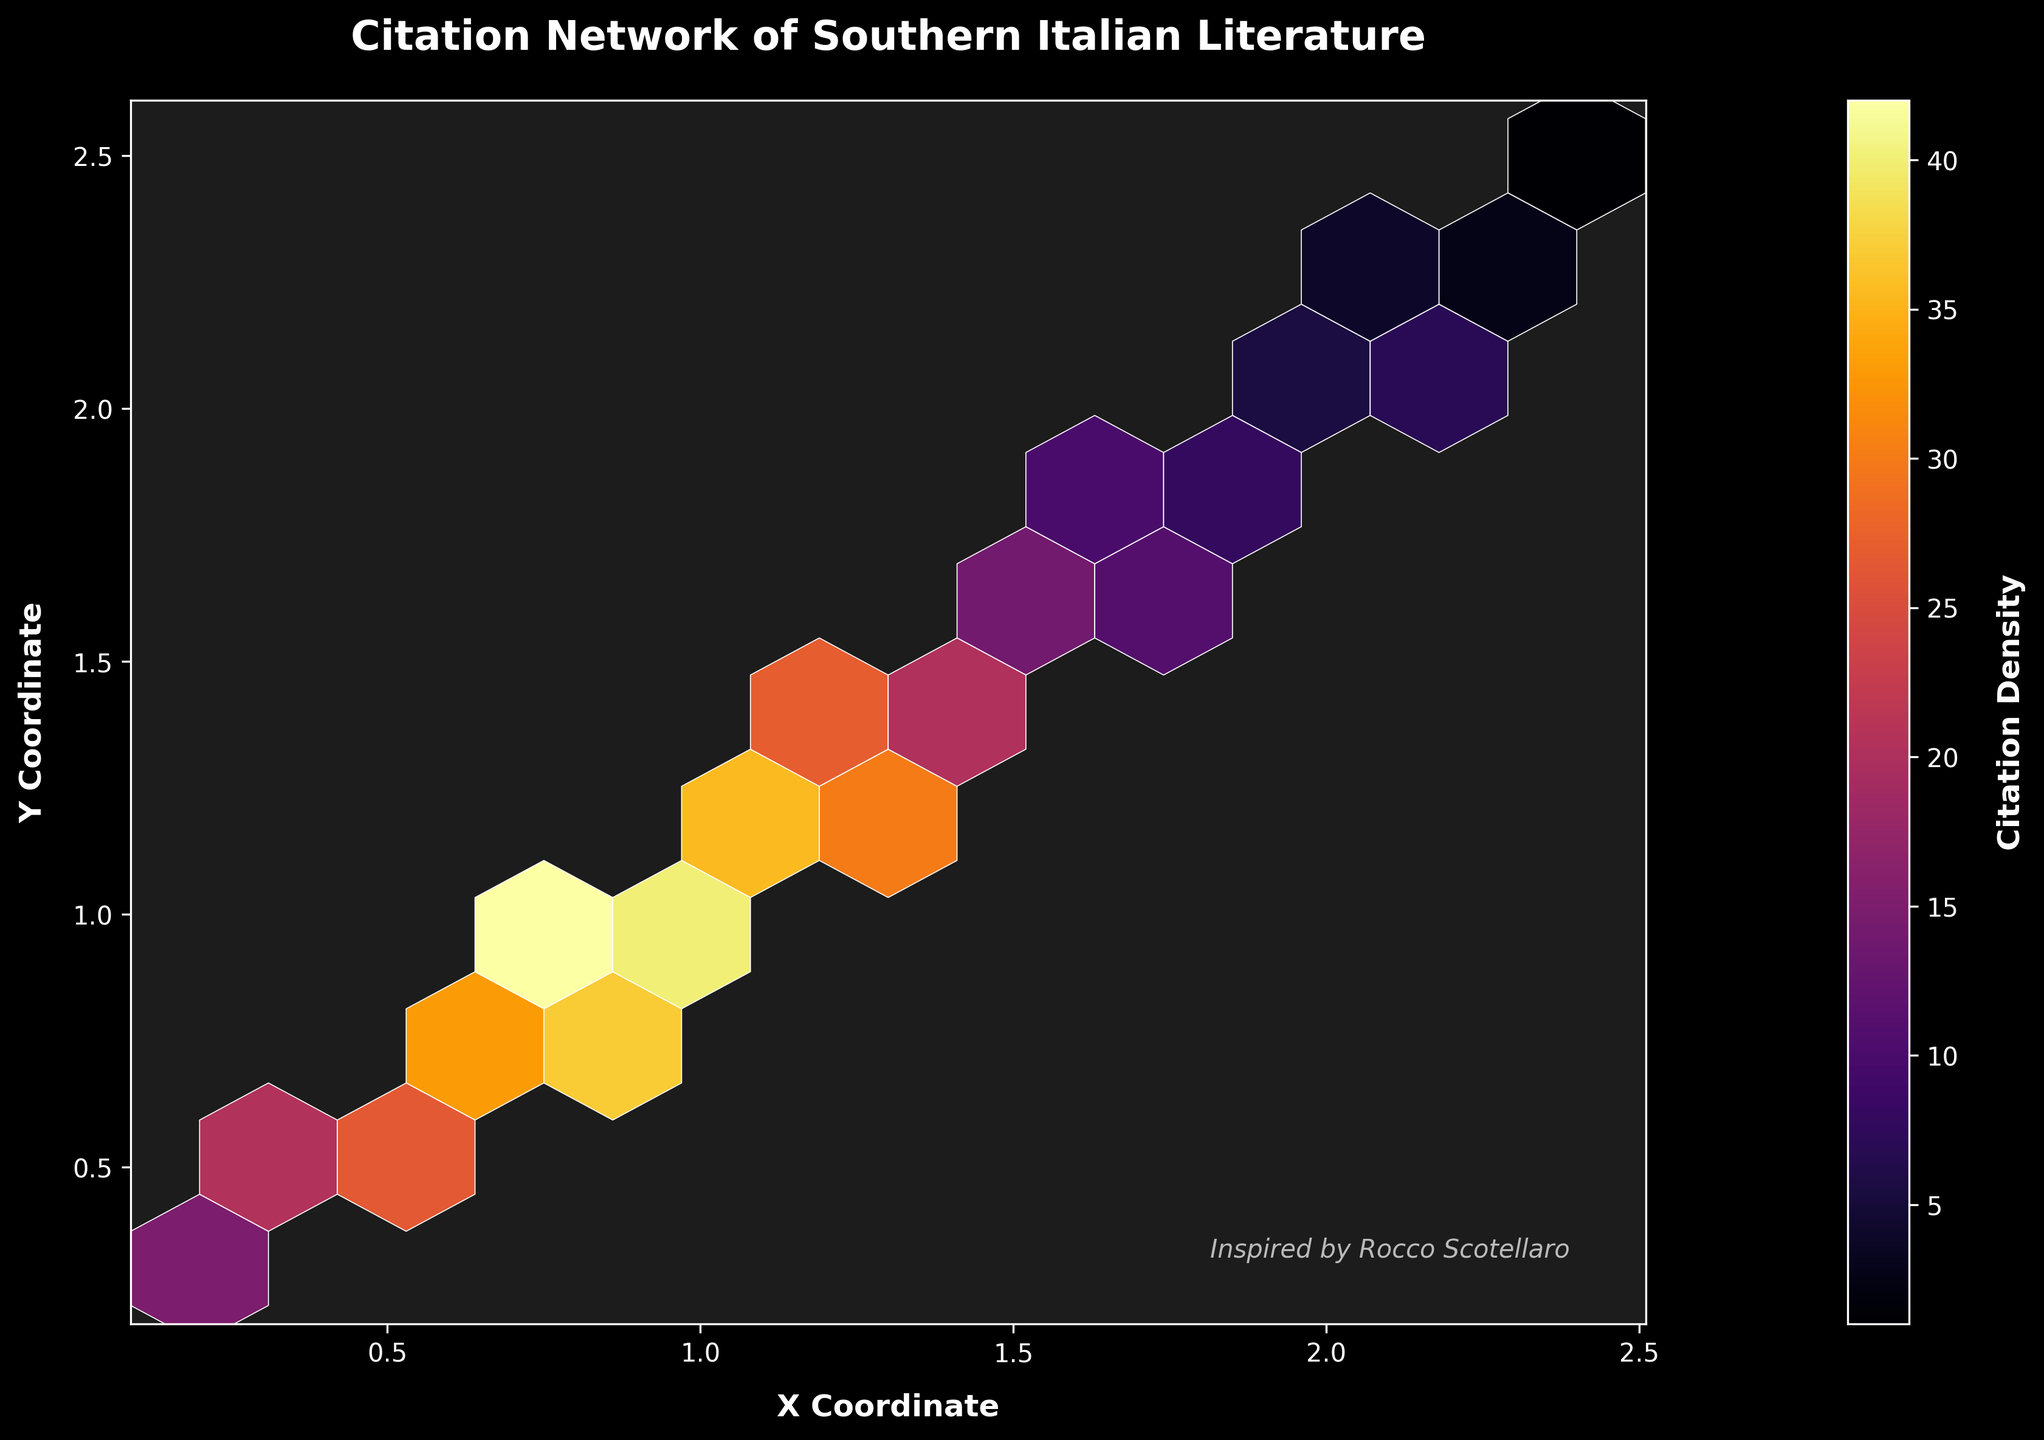What is the title of the plot? Look at the top of the figure where the title is usually located. It reads "Citation Network of Southern Italian Literature".
Answer: Citation Network of Southern Italian Literature What does the colorbar represent? A colorbar is usually placed next to the plot to show what the colors represent. Here, it is labeled as "Citation Density".
Answer: Citation Density Which of the two coordinates, X or Y, has higher values concentrated in the plot? By examining the plot, the density of darker/heavier colors (representing higher citation density) is more concentrated in the middle range of both the X and Y coordinates, but particularly noticeable along the X axis.
Answer: X Coordinate What color scheme is used in the plot? Looking at the colors in the plot, the plot uses a gradient that goes from yellow to dark red as shown in the colorbar, which corresponds to the "inferno" color scheme.
Answer: Inferno Where on the plot are the highest citation densities located? The highest citation densities are indicated by the darkest hexagons. By examining the plot, they seem to be clustered around the middle sections of the X and Y axes, particularly around the coordinates (1, 1).
Answer: Around (1, 1) What is the grid size of the hexbin plot? By counting the hexagons along one axis and confirming it with the figure's description, the grid size is determined to be 10.
Answer: 10 How many points have the highest citation density? The colorbar shows the range of citation densities. By checking the hexagons' colors against the darkest color in the colorbar, it seems that very few (maybe 1 or 2) hexagons hold the highest citation density.
Answer: 1 or 2 Which axis has a label written in bold text? By looking at the axes, the labeling style is noticed. Both the X and Y axes labels are written in bold text, labeled as "X Coordinate" and "Y Coordinate".
Answer: Both What is the position of the text inspired by Rocco Scotellaro? Look at the plot for additional text. The text "Inspired by Rocco Scotellaro" is located at the bottom right corner of the plot, as indicated by its position description.
Answer: Bottom right corner 